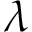<formula> <loc_0><loc_0><loc_500><loc_500>\lambda</formula> 